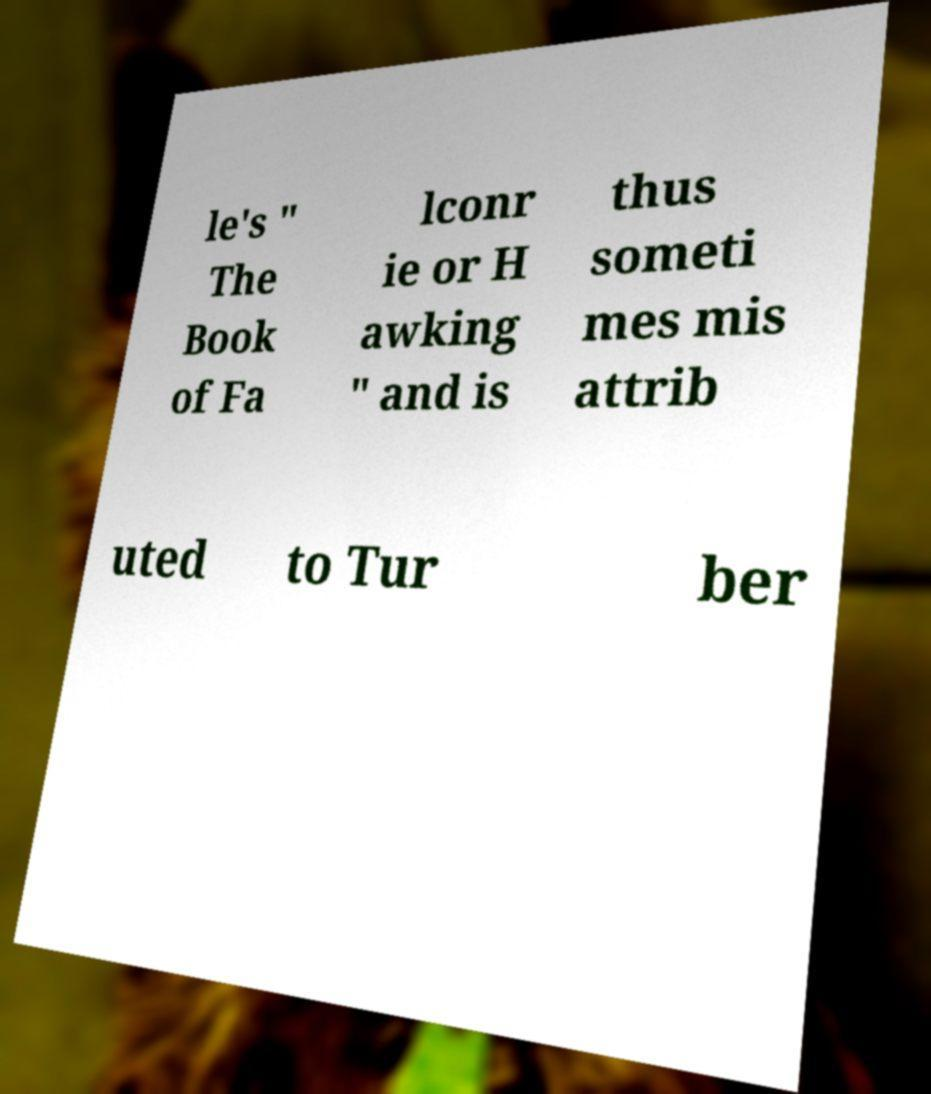I need the written content from this picture converted into text. Can you do that? le's " The Book of Fa lconr ie or H awking " and is thus someti mes mis attrib uted to Tur ber 